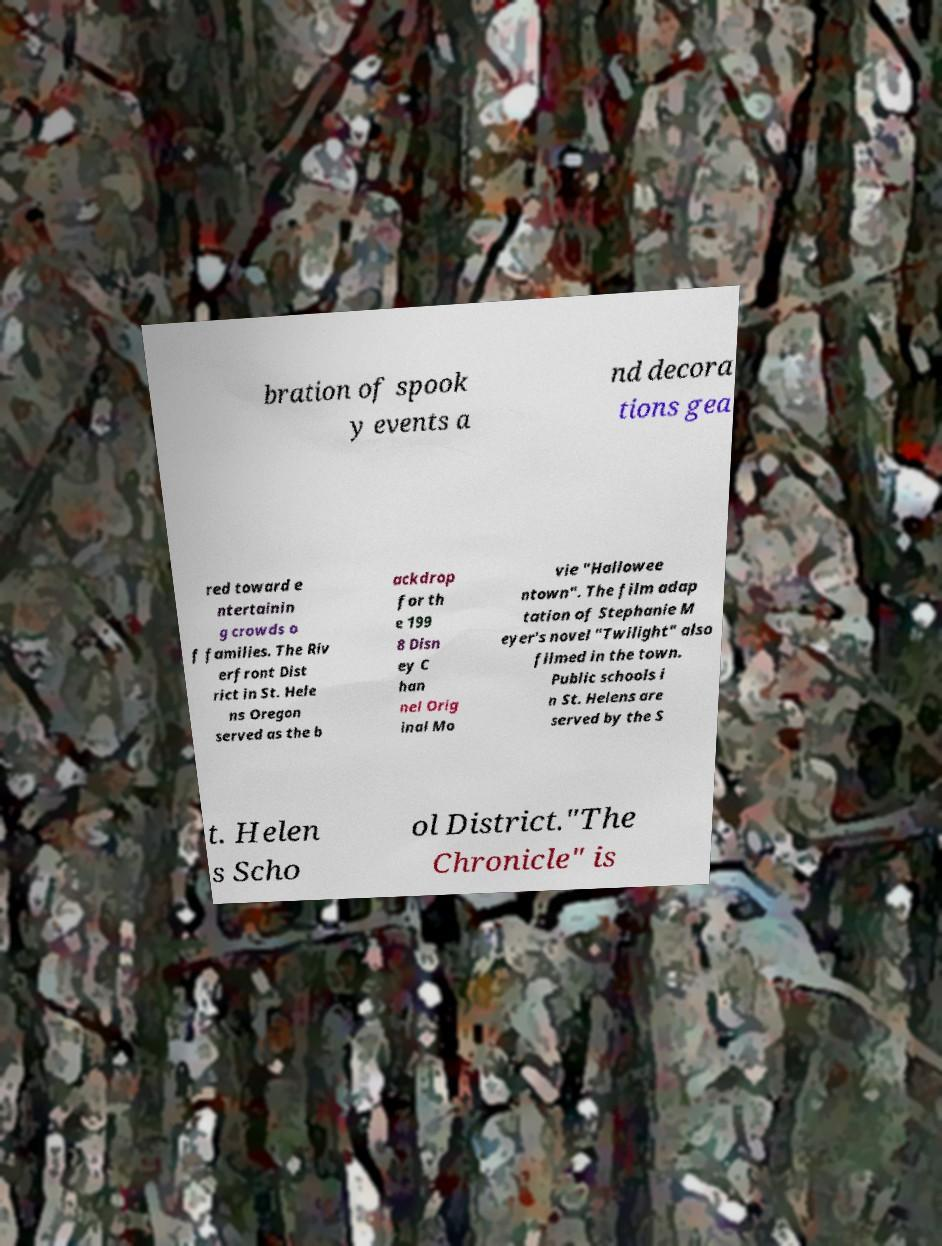Please identify and transcribe the text found in this image. bration of spook y events a nd decora tions gea red toward e ntertainin g crowds o f families. The Riv erfront Dist rict in St. Hele ns Oregon served as the b ackdrop for th e 199 8 Disn ey C han nel Orig inal Mo vie "Hallowee ntown". The film adap tation of Stephanie M eyer's novel "Twilight" also filmed in the town. Public schools i n St. Helens are served by the S t. Helen s Scho ol District."The Chronicle" is 